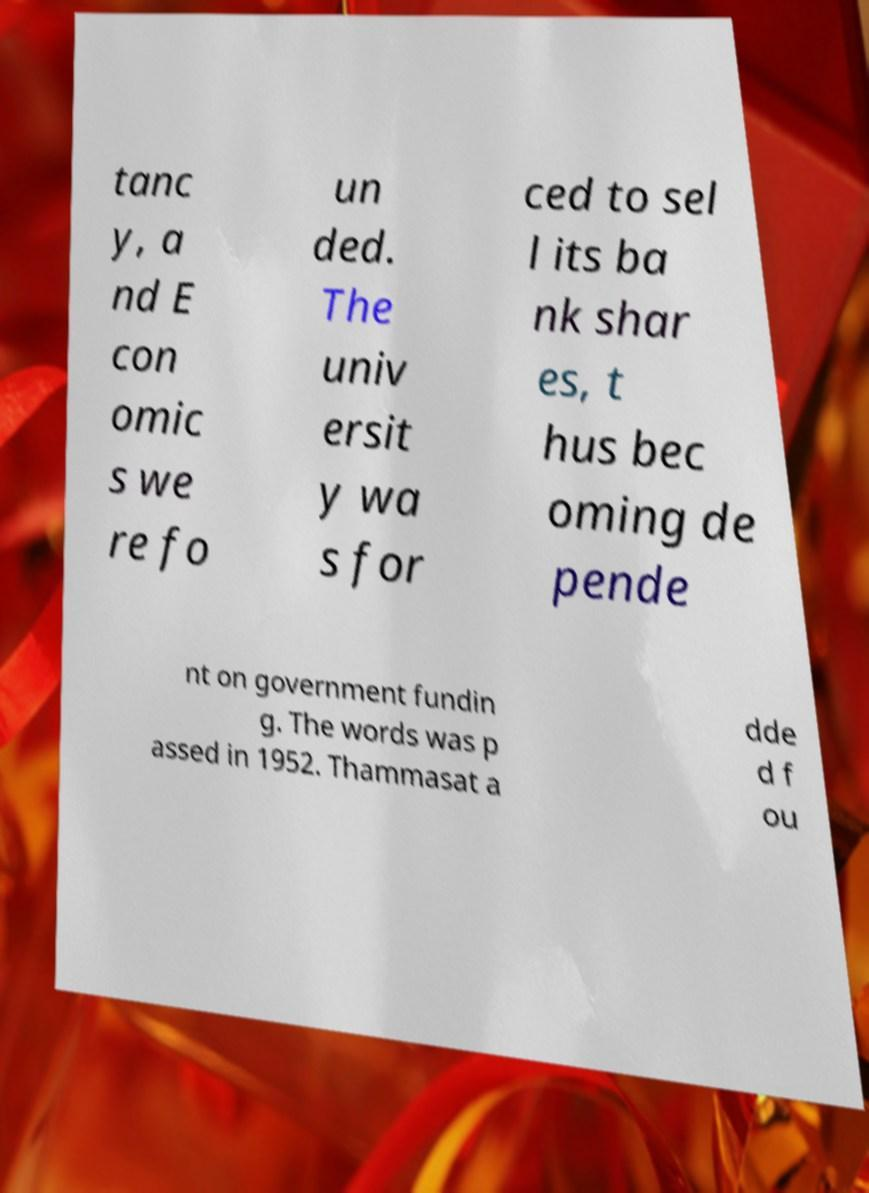For documentation purposes, I need the text within this image transcribed. Could you provide that? tanc y, a nd E con omic s we re fo un ded. The univ ersit y wa s for ced to sel l its ba nk shar es, t hus bec oming de pende nt on government fundin g. The words was p assed in 1952. Thammasat a dde d f ou 